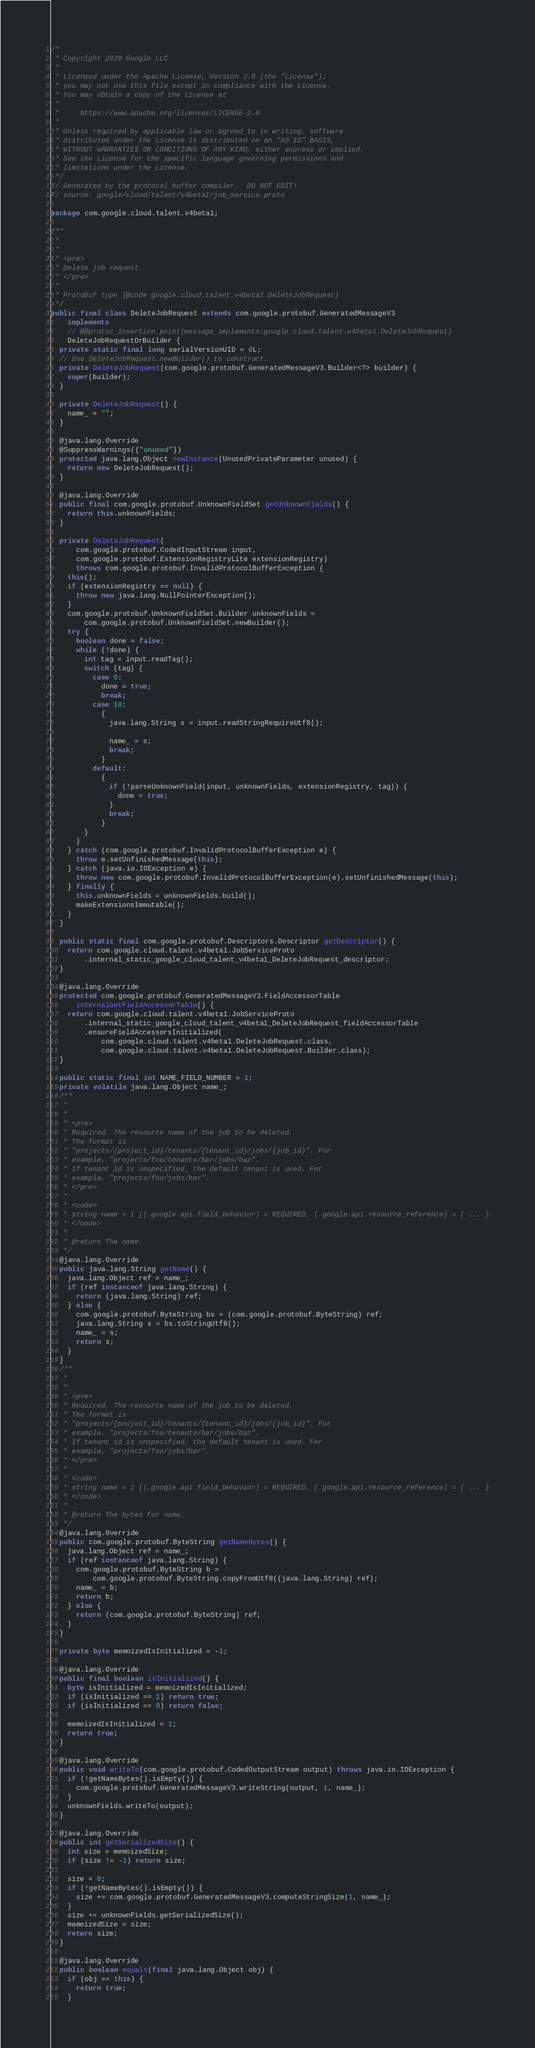<code> <loc_0><loc_0><loc_500><loc_500><_Java_>/*
 * Copyright 2020 Google LLC
 *
 * Licensed under the Apache License, Version 2.0 (the "License");
 * you may not use this file except in compliance with the License.
 * You may obtain a copy of the License at
 *
 *     https://www.apache.org/licenses/LICENSE-2.0
 *
 * Unless required by applicable law or agreed to in writing, software
 * distributed under the License is distributed on an "AS IS" BASIS,
 * WITHOUT WARRANTIES OR CONDITIONS OF ANY KIND, either express or implied.
 * See the License for the specific language governing permissions and
 * limitations under the License.
 */
// Generated by the protocol buffer compiler.  DO NOT EDIT!
// source: google/cloud/talent/v4beta1/job_service.proto

package com.google.cloud.talent.v4beta1;

/**
 *
 *
 * <pre>
 * Delete job request.
 * </pre>
 *
 * Protobuf type {@code google.cloud.talent.v4beta1.DeleteJobRequest}
 */
public final class DeleteJobRequest extends com.google.protobuf.GeneratedMessageV3
    implements
    // @@protoc_insertion_point(message_implements:google.cloud.talent.v4beta1.DeleteJobRequest)
    DeleteJobRequestOrBuilder {
  private static final long serialVersionUID = 0L;
  // Use DeleteJobRequest.newBuilder() to construct.
  private DeleteJobRequest(com.google.protobuf.GeneratedMessageV3.Builder<?> builder) {
    super(builder);
  }

  private DeleteJobRequest() {
    name_ = "";
  }

  @java.lang.Override
  @SuppressWarnings({"unused"})
  protected java.lang.Object newInstance(UnusedPrivateParameter unused) {
    return new DeleteJobRequest();
  }

  @java.lang.Override
  public final com.google.protobuf.UnknownFieldSet getUnknownFields() {
    return this.unknownFields;
  }

  private DeleteJobRequest(
      com.google.protobuf.CodedInputStream input,
      com.google.protobuf.ExtensionRegistryLite extensionRegistry)
      throws com.google.protobuf.InvalidProtocolBufferException {
    this();
    if (extensionRegistry == null) {
      throw new java.lang.NullPointerException();
    }
    com.google.protobuf.UnknownFieldSet.Builder unknownFields =
        com.google.protobuf.UnknownFieldSet.newBuilder();
    try {
      boolean done = false;
      while (!done) {
        int tag = input.readTag();
        switch (tag) {
          case 0:
            done = true;
            break;
          case 10:
            {
              java.lang.String s = input.readStringRequireUtf8();

              name_ = s;
              break;
            }
          default:
            {
              if (!parseUnknownField(input, unknownFields, extensionRegistry, tag)) {
                done = true;
              }
              break;
            }
        }
      }
    } catch (com.google.protobuf.InvalidProtocolBufferException e) {
      throw e.setUnfinishedMessage(this);
    } catch (java.io.IOException e) {
      throw new com.google.protobuf.InvalidProtocolBufferException(e).setUnfinishedMessage(this);
    } finally {
      this.unknownFields = unknownFields.build();
      makeExtensionsImmutable();
    }
  }

  public static final com.google.protobuf.Descriptors.Descriptor getDescriptor() {
    return com.google.cloud.talent.v4beta1.JobServiceProto
        .internal_static_google_cloud_talent_v4beta1_DeleteJobRequest_descriptor;
  }

  @java.lang.Override
  protected com.google.protobuf.GeneratedMessageV3.FieldAccessorTable
      internalGetFieldAccessorTable() {
    return com.google.cloud.talent.v4beta1.JobServiceProto
        .internal_static_google_cloud_talent_v4beta1_DeleteJobRequest_fieldAccessorTable
        .ensureFieldAccessorsInitialized(
            com.google.cloud.talent.v4beta1.DeleteJobRequest.class,
            com.google.cloud.talent.v4beta1.DeleteJobRequest.Builder.class);
  }

  public static final int NAME_FIELD_NUMBER = 1;
  private volatile java.lang.Object name_;
  /**
   *
   *
   * <pre>
   * Required. The resource name of the job to be deleted.
   * The format is
   * "projects/{project_id}/tenants/{tenant_id}/jobs/{job_id}". For
   * example, "projects/foo/tenants/bar/jobs/baz".
   * If tenant id is unspecified, the default tenant is used. For
   * example, "projects/foo/jobs/bar".
   * </pre>
   *
   * <code>
   * string name = 1 [(.google.api.field_behavior) = REQUIRED, (.google.api.resource_reference) = { ... }
   * </code>
   *
   * @return The name.
   */
  @java.lang.Override
  public java.lang.String getName() {
    java.lang.Object ref = name_;
    if (ref instanceof java.lang.String) {
      return (java.lang.String) ref;
    } else {
      com.google.protobuf.ByteString bs = (com.google.protobuf.ByteString) ref;
      java.lang.String s = bs.toStringUtf8();
      name_ = s;
      return s;
    }
  }
  /**
   *
   *
   * <pre>
   * Required. The resource name of the job to be deleted.
   * The format is
   * "projects/{project_id}/tenants/{tenant_id}/jobs/{job_id}". For
   * example, "projects/foo/tenants/bar/jobs/baz".
   * If tenant id is unspecified, the default tenant is used. For
   * example, "projects/foo/jobs/bar".
   * </pre>
   *
   * <code>
   * string name = 1 [(.google.api.field_behavior) = REQUIRED, (.google.api.resource_reference) = { ... }
   * </code>
   *
   * @return The bytes for name.
   */
  @java.lang.Override
  public com.google.protobuf.ByteString getNameBytes() {
    java.lang.Object ref = name_;
    if (ref instanceof java.lang.String) {
      com.google.protobuf.ByteString b =
          com.google.protobuf.ByteString.copyFromUtf8((java.lang.String) ref);
      name_ = b;
      return b;
    } else {
      return (com.google.protobuf.ByteString) ref;
    }
  }

  private byte memoizedIsInitialized = -1;

  @java.lang.Override
  public final boolean isInitialized() {
    byte isInitialized = memoizedIsInitialized;
    if (isInitialized == 1) return true;
    if (isInitialized == 0) return false;

    memoizedIsInitialized = 1;
    return true;
  }

  @java.lang.Override
  public void writeTo(com.google.protobuf.CodedOutputStream output) throws java.io.IOException {
    if (!getNameBytes().isEmpty()) {
      com.google.protobuf.GeneratedMessageV3.writeString(output, 1, name_);
    }
    unknownFields.writeTo(output);
  }

  @java.lang.Override
  public int getSerializedSize() {
    int size = memoizedSize;
    if (size != -1) return size;

    size = 0;
    if (!getNameBytes().isEmpty()) {
      size += com.google.protobuf.GeneratedMessageV3.computeStringSize(1, name_);
    }
    size += unknownFields.getSerializedSize();
    memoizedSize = size;
    return size;
  }

  @java.lang.Override
  public boolean equals(final java.lang.Object obj) {
    if (obj == this) {
      return true;
    }</code> 